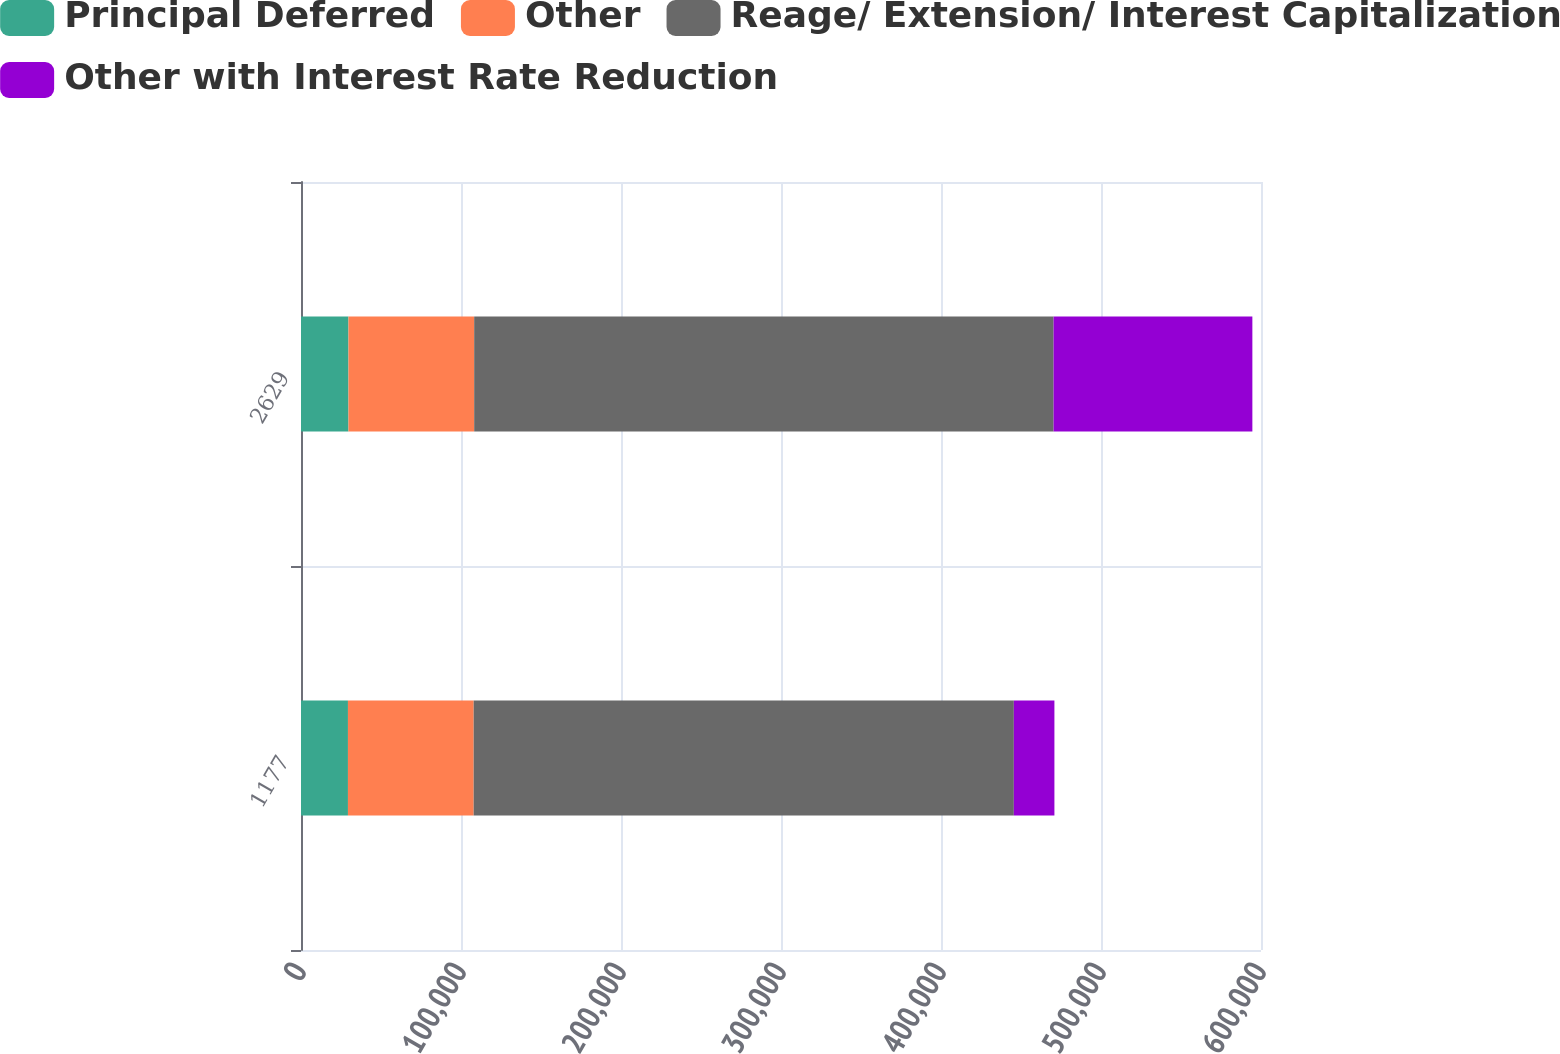<chart> <loc_0><loc_0><loc_500><loc_500><stacked_bar_chart><ecel><fcel>1177<fcel>2629<nl><fcel>Principal Deferred<fcel>29343<fcel>29660<nl><fcel>Other<fcel>78582<fcel>78582<nl><fcel>Reage/ Extension/ Interest Capitalization<fcel>337604<fcel>362135<nl><fcel>Other with Interest Rate Reduction<fcel>25354<fcel>124227<nl></chart> 